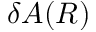Convert formula to latex. <formula><loc_0><loc_0><loc_500><loc_500>\delta A ( R )</formula> 